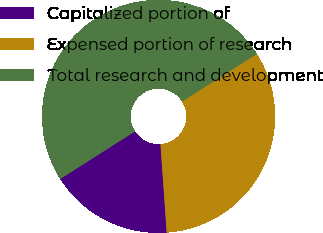Convert chart to OTSL. <chart><loc_0><loc_0><loc_500><loc_500><pie_chart><fcel>Capitalized portion of<fcel>Expensed portion of research<fcel>Total research and development<nl><fcel>17.1%<fcel>32.9%<fcel>50.0%<nl></chart> 